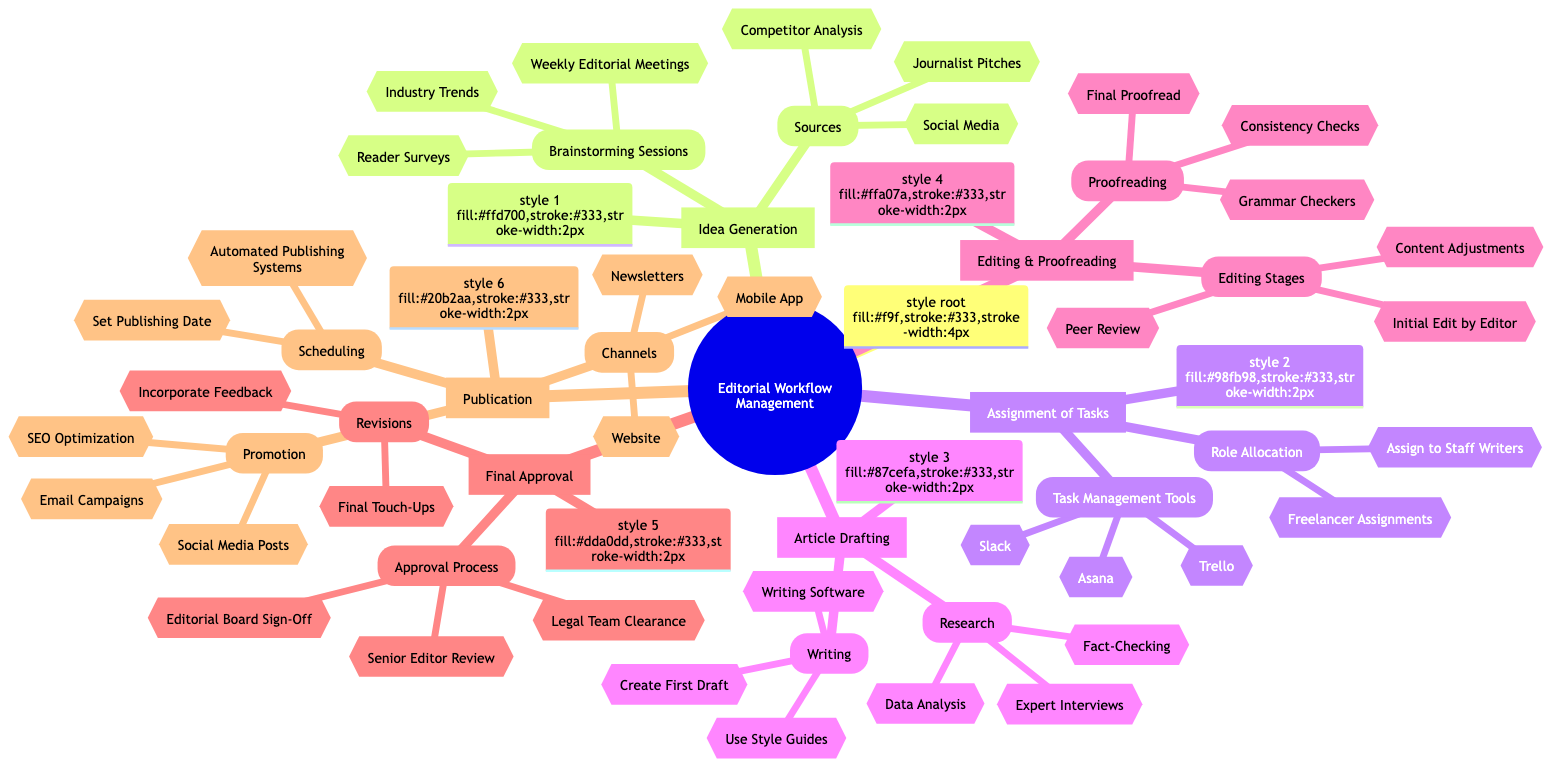what are the main stages of the Editorial Workflow Management? The diagram outlines six main stages which are Idea Generation, Assignment of Tasks, Article Drafting, Editing & Proofreading, Final Approval, and Publication.
Answer: Idea Generation, Assignment of Tasks, Article Drafting, Editing & Proofreading, Final Approval, Publication how many brainstorming session types are listed? In the Idea Generation section, there are three types of brainstorming sessions mentioned: Weekly Editorial Meetings, Reader Surveys, and Industry Trends.
Answer: 3 which tools are suggested for task management? The Assignment of Tasks section lists three task management tools: Trello, Asana, and Slack.
Answer: Trello, Asana, Slack what is the last step before publication? The last step before publication, according to the diagram, is the Final Approval stage, which includes processes like Senior Editor Review.
Answer: Final Approval which stage includes grammar checkers? Grammar Checkers are included in the Editing & Proofreading stage, specifically under the Proofreading subsection.
Answer: Editing & Proofreading what is one of the promotion methods listed in the Publication stage? The Promotion section of Publication includes Social Media Posts as one of the methods for promoting published content.
Answer: Social Media Posts how many sources are listed for Idea Generation? There are three sources listed in the Idea Generation section: Social Media, Competitor Analysis, and Journalist Pitches.
Answer: 3 which team clears legal aspects in the Final Approval stage? The diagram identifies the Legal Team as responsible for clearance during the Final Approval process.
Answer: Legal Team what are the channels mentioned for publication? The Publication section specifies three channels: Website, Mobile App, and Newsletters where articles can be published.
Answer: Website, Mobile App, Newsletters 